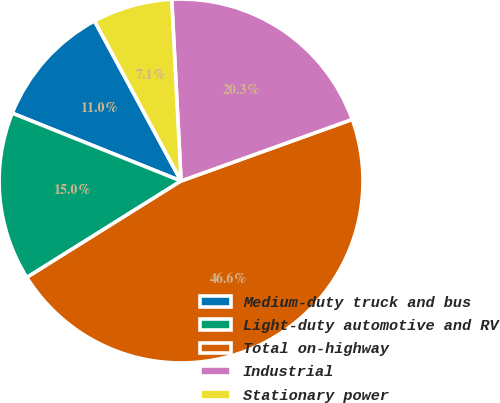<chart> <loc_0><loc_0><loc_500><loc_500><pie_chart><fcel>Medium-duty truck and bus<fcel>Light-duty automotive and RV<fcel>Total on-highway<fcel>Industrial<fcel>Stationary power<nl><fcel>11.03%<fcel>14.98%<fcel>46.6%<fcel>20.32%<fcel>7.07%<nl></chart> 